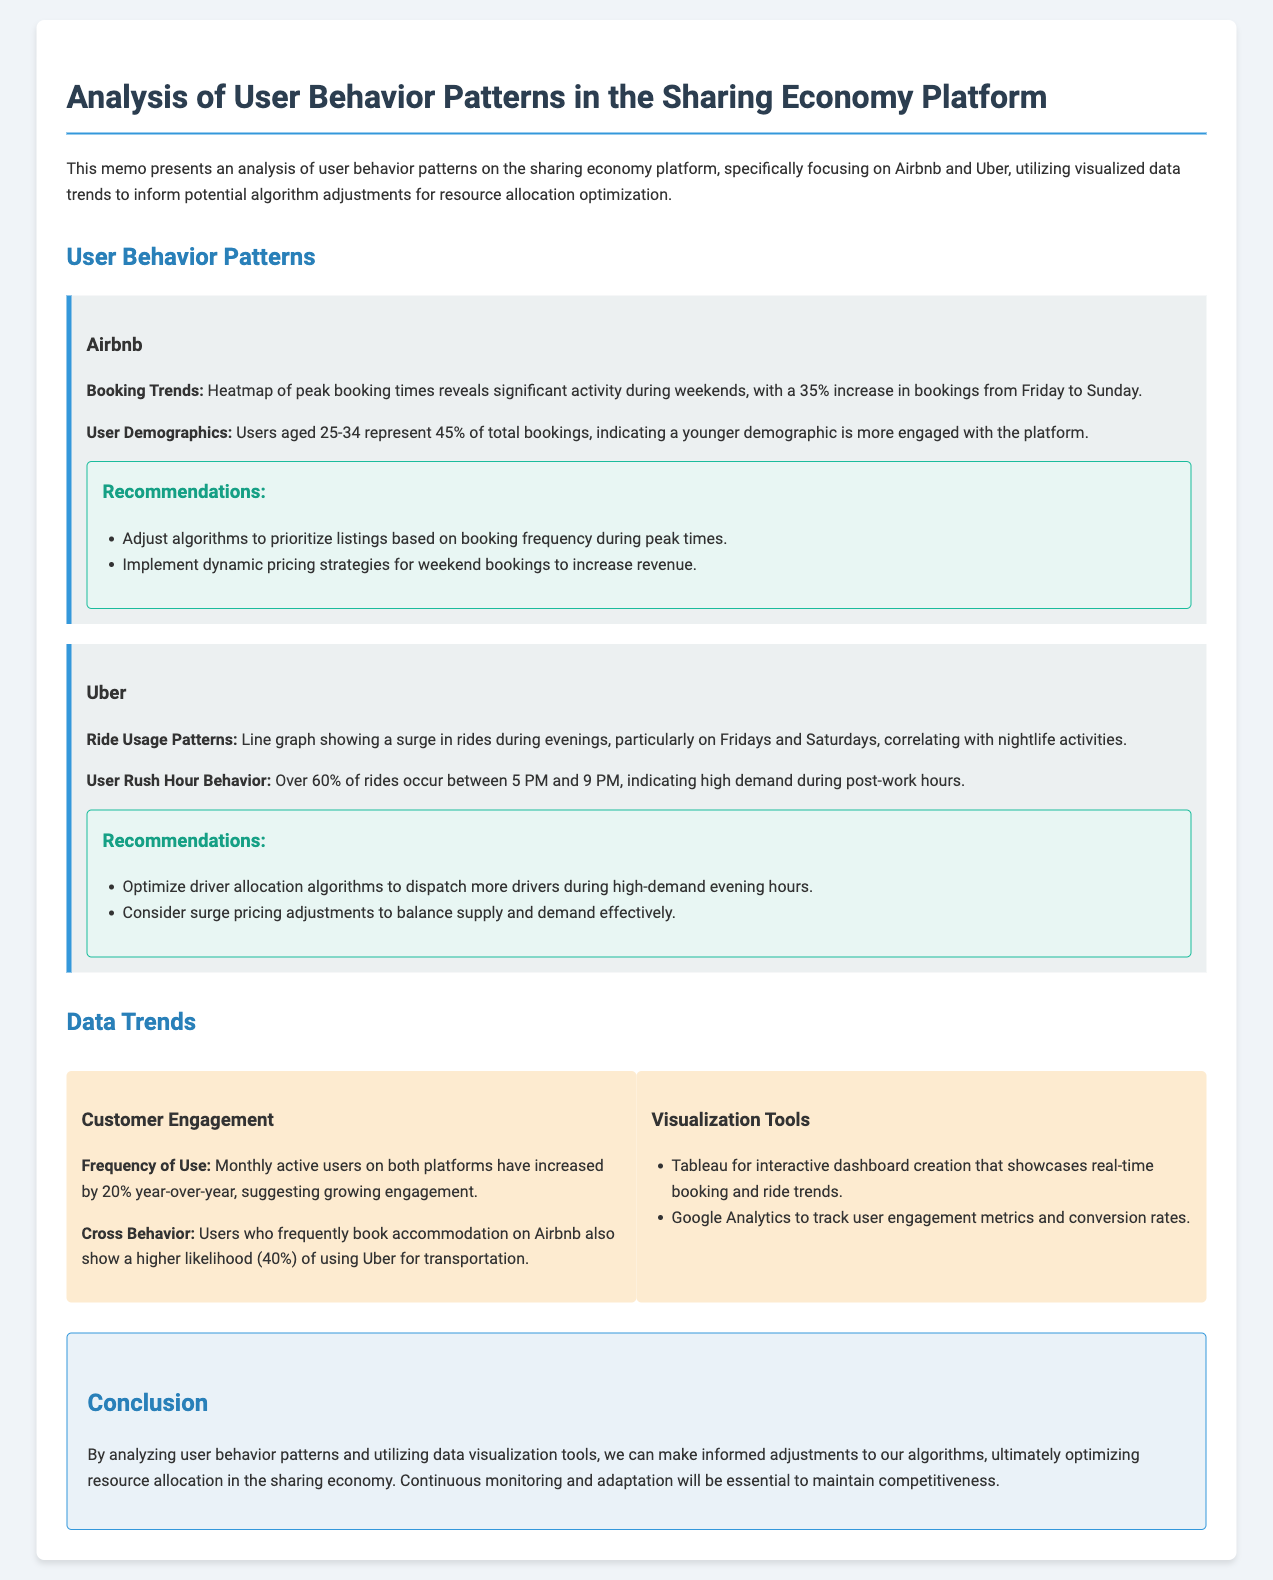What is the increase in Airbnb bookings from Friday to Sunday? The report indicates a significant activity during weekends, with a 35% increase in bookings from Friday to Sunday.
Answer: 35% What percentage of total bookings on Airbnb are from users aged 25-34? The document states that users aged 25-34 represent 45% of total bookings, indicating the demographic engagement.
Answer: 45% What time frame sees high ride usage on Uber? The memo specifies that over 60% of rides occur between 5 PM and 9 PM, highlighting peak demand hours.
Answer: 5 PM to 9 PM What tool is mentioned for creating interactive dashboards? The document lists Tableau as a visualization tool for interactive dashboard creation that showcases real-time booking and ride trends.
Answer: Tableau What recommendation is made for Airbnb listings during peak times? One suggested adjustment is to prioritize listings based on booking frequency during peak times, aiming to optimize resource allocation.
Answer: Prioritize listings based on booking frequency Which platform shows user behavior cross-relation with a 40% likelihood? The memo indicates that users who frequently book accommodation on Airbnb also show a higher likelihood of using Uber for transportation, specifically a 40% correlation.
Answer: Airbnb What is the year-over-year increase in monthly active users for both platforms? The analysis reveals that monthly active users on both platforms have increased by 20% year-over-year, suggesting growing engagement and activity.
Answer: 20% What do the recommendations for Uber suggest regarding driver allocation? One recommendation is to optimize driver allocation algorithms to dispatch more drivers during high-demand evening hours, reflecting a focus on efficiency.
Answer: Optimize driver allocation algorithms What is the main conclusion drawn in the document? The conclusion emphasizes the need for informed adjustments to algorithms through user behavior analysis and data visualization, to enhance resource allocation.
Answer: Optimize resource allocation 